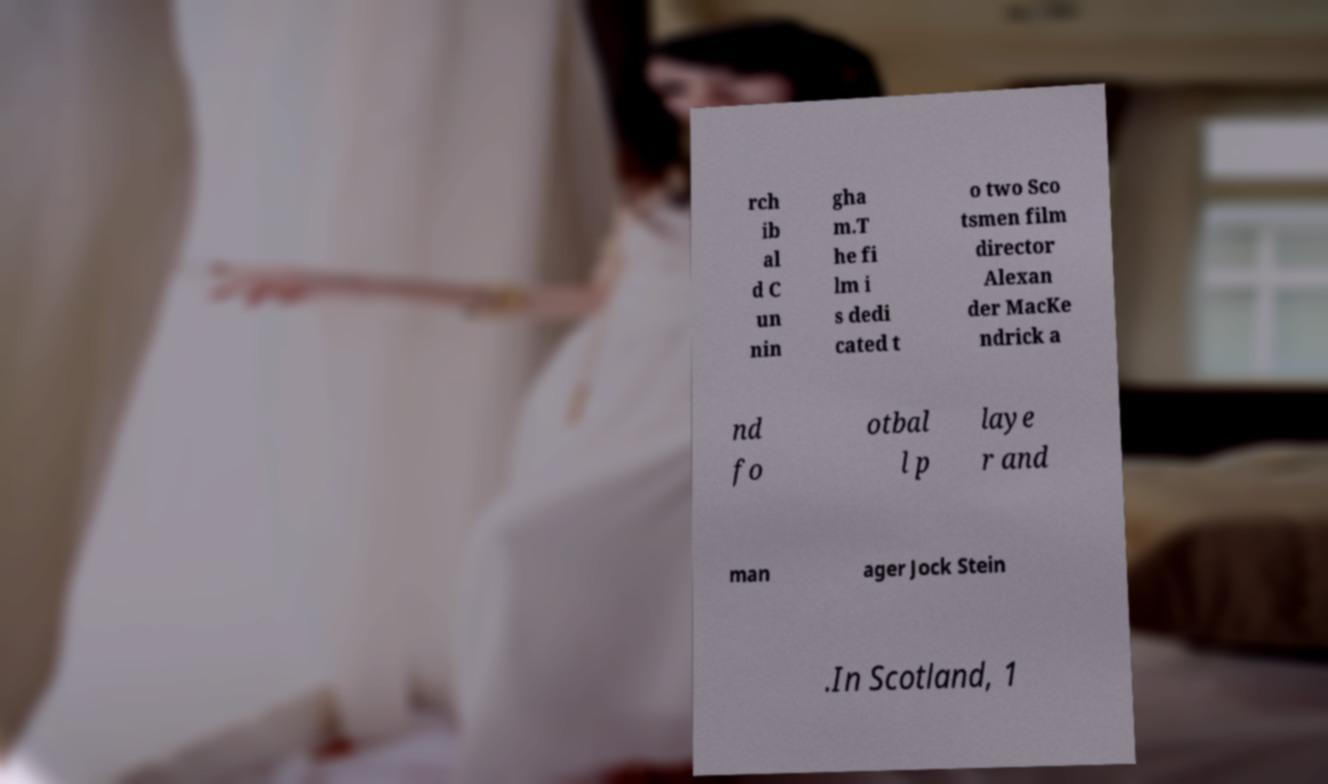Please identify and transcribe the text found in this image. rch ib al d C un nin gha m.T he fi lm i s dedi cated t o two Sco tsmen film director Alexan der MacKe ndrick a nd fo otbal l p laye r and man ager Jock Stein .In Scotland, 1 